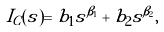<formula> <loc_0><loc_0><loc_500><loc_500>I _ { C } ( s ) = b _ { 1 } s ^ { \beta _ { 1 } } + b _ { 2 } s ^ { \beta _ { 2 } } ,</formula> 